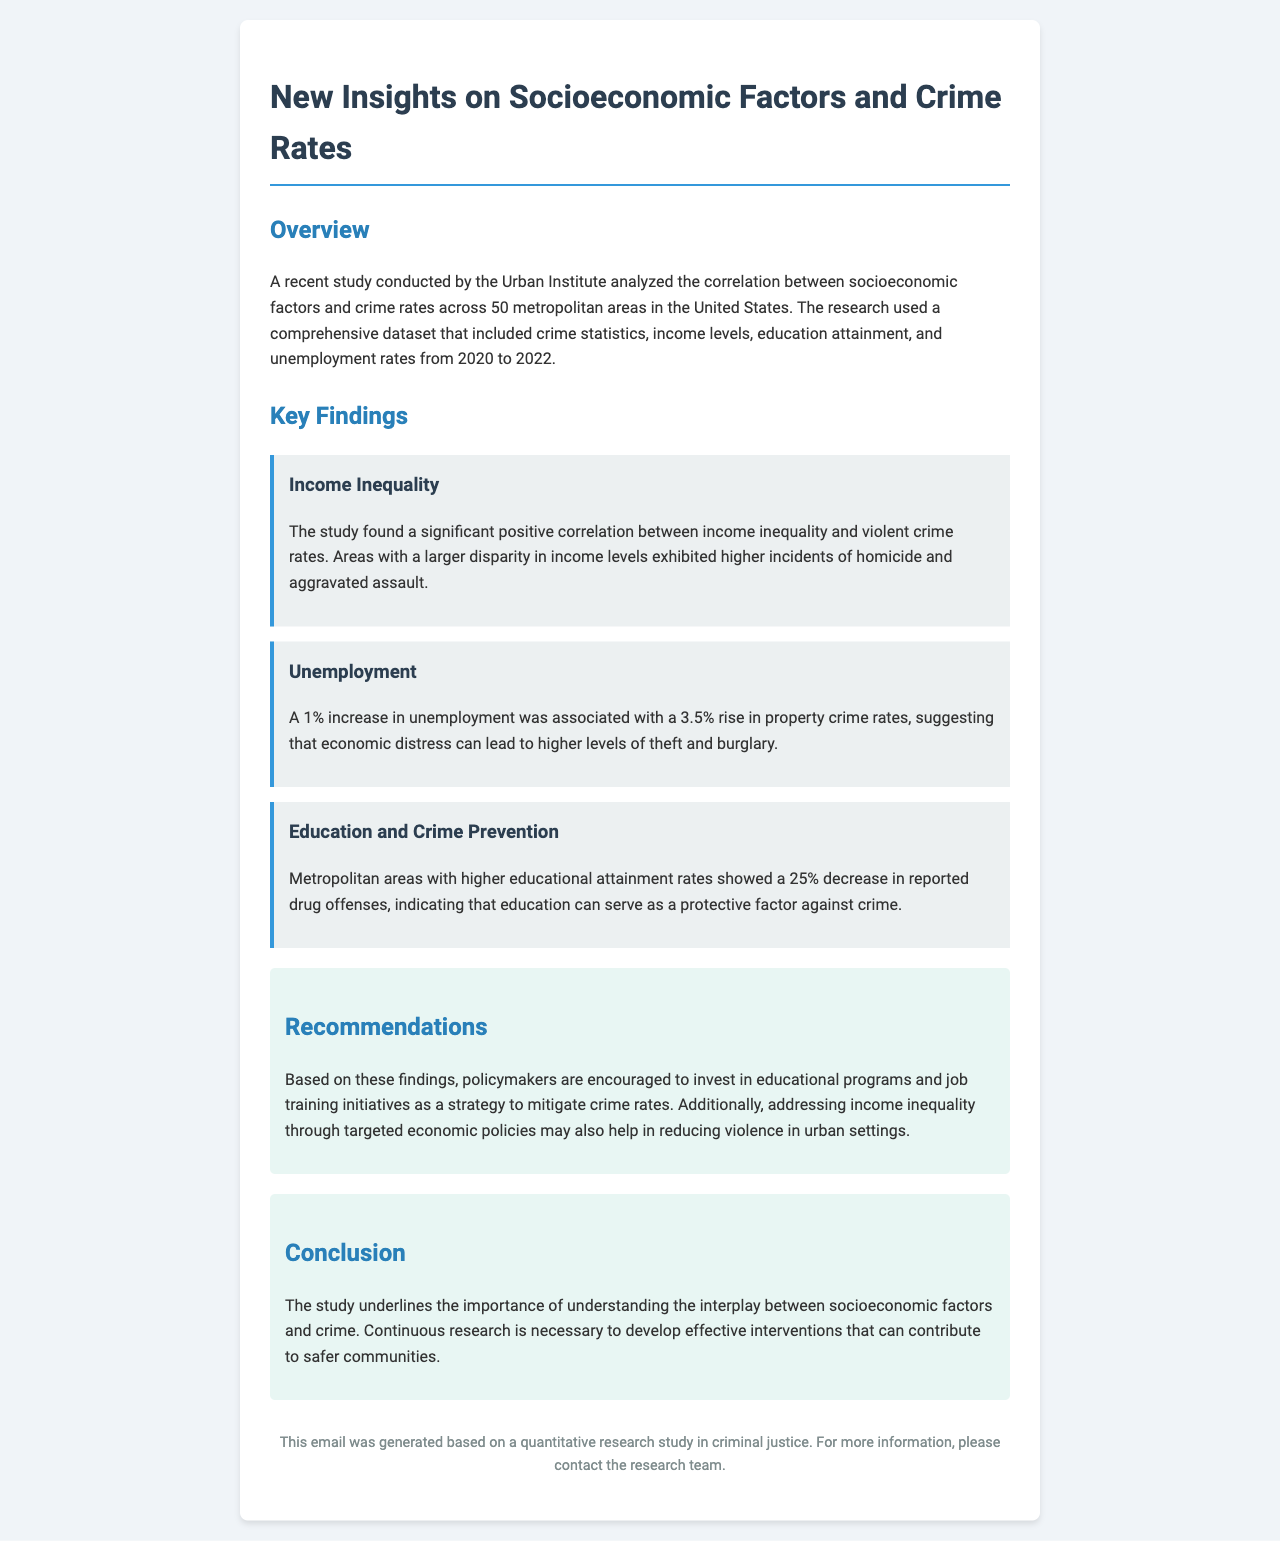What organization conducted the study? The study was conducted by the Urban Institute, as mentioned in the overview section of the document.
Answer: Urban Institute What period did the study cover? The study covered crime statistics, income levels, education attainment, and unemployment rates from 2020 to 2022, as stated in the overview.
Answer: 2020 to 2022 What type of crime showed a positive correlation with income inequality? The document specifies that violent crime rates, particularly homicide and aggravated assault, are positively correlated with income inequality.
Answer: Violent crime How much does a 1% increase in unemployment affect property crime rates? The document states that a 1% increase in unemployment is associated with a 3.5% rise in property crime rates.
Answer: 3.5% What is the percentage decrease in drug offenses with higher educational attainment? The findings indicate that there is a 25% decrease in reported drug offenses in areas with higher educational attainment.
Answer: 25% What do the recommendations suggest policymakers invest in? The recommendations encourage investment in educational programs and job training initiatives to mitigate crime rates.
Answer: Educational programs and job training initiatives What year did the research team suggest ongoing investigation is necessary? The conclusion emphasizes the necessity for continuous research but does not specify a year. The focus is on the ongoing need for understanding socioeconomic factors and crime.
Answer: Ongoing What document type is this email based on? The email concludes by noting that it was generated based on a quantitative research study in criminal justice.
Answer: Quantitative research study 